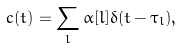<formula> <loc_0><loc_0><loc_500><loc_500>c ( t ) = \sum _ { l } \alpha [ l ] \delta ( t - \tau _ { l } ) ,</formula> 